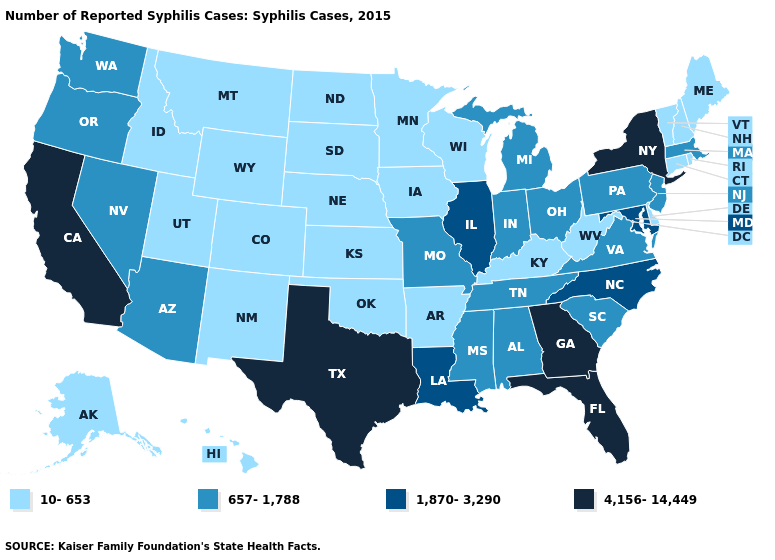What is the highest value in the West ?
Answer briefly. 4,156-14,449. How many symbols are there in the legend?
Quick response, please. 4. Does the first symbol in the legend represent the smallest category?
Short answer required. Yes. Does North Dakota have the same value as Mississippi?
Keep it brief. No. Name the states that have a value in the range 10-653?
Keep it brief. Alaska, Arkansas, Colorado, Connecticut, Delaware, Hawaii, Idaho, Iowa, Kansas, Kentucky, Maine, Minnesota, Montana, Nebraska, New Hampshire, New Mexico, North Dakota, Oklahoma, Rhode Island, South Dakota, Utah, Vermont, West Virginia, Wisconsin, Wyoming. What is the lowest value in the West?
Answer briefly. 10-653. Which states hav the highest value in the South?
Concise answer only. Florida, Georgia, Texas. Among the states that border New York , which have the highest value?
Short answer required. Massachusetts, New Jersey, Pennsylvania. Is the legend a continuous bar?
Write a very short answer. No. What is the value of Utah?
Answer briefly. 10-653. What is the lowest value in states that border Missouri?
Give a very brief answer. 10-653. Name the states that have a value in the range 10-653?
Write a very short answer. Alaska, Arkansas, Colorado, Connecticut, Delaware, Hawaii, Idaho, Iowa, Kansas, Kentucky, Maine, Minnesota, Montana, Nebraska, New Hampshire, New Mexico, North Dakota, Oklahoma, Rhode Island, South Dakota, Utah, Vermont, West Virginia, Wisconsin, Wyoming. Name the states that have a value in the range 10-653?
Be succinct. Alaska, Arkansas, Colorado, Connecticut, Delaware, Hawaii, Idaho, Iowa, Kansas, Kentucky, Maine, Minnesota, Montana, Nebraska, New Hampshire, New Mexico, North Dakota, Oklahoma, Rhode Island, South Dakota, Utah, Vermont, West Virginia, Wisconsin, Wyoming. Does Illinois have the highest value in the MidWest?
Keep it brief. Yes. What is the lowest value in the USA?
Give a very brief answer. 10-653. 